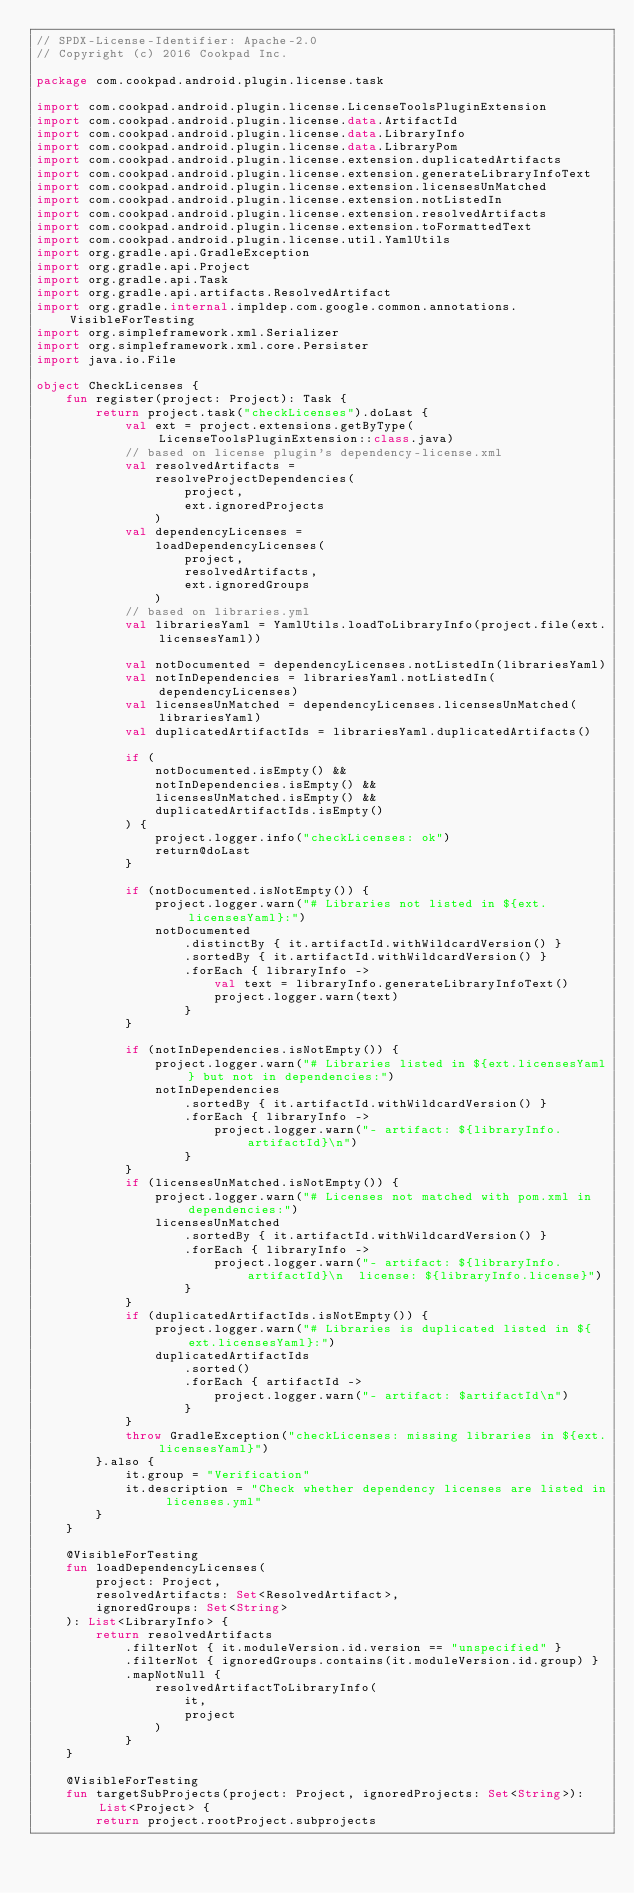Convert code to text. <code><loc_0><loc_0><loc_500><loc_500><_Kotlin_>// SPDX-License-Identifier: Apache-2.0
// Copyright (c) 2016 Cookpad Inc.

package com.cookpad.android.plugin.license.task

import com.cookpad.android.plugin.license.LicenseToolsPluginExtension
import com.cookpad.android.plugin.license.data.ArtifactId
import com.cookpad.android.plugin.license.data.LibraryInfo
import com.cookpad.android.plugin.license.data.LibraryPom
import com.cookpad.android.plugin.license.extension.duplicatedArtifacts
import com.cookpad.android.plugin.license.extension.generateLibraryInfoText
import com.cookpad.android.plugin.license.extension.licensesUnMatched
import com.cookpad.android.plugin.license.extension.notListedIn
import com.cookpad.android.plugin.license.extension.resolvedArtifacts
import com.cookpad.android.plugin.license.extension.toFormattedText
import com.cookpad.android.plugin.license.util.YamlUtils
import org.gradle.api.GradleException
import org.gradle.api.Project
import org.gradle.api.Task
import org.gradle.api.artifacts.ResolvedArtifact
import org.gradle.internal.impldep.com.google.common.annotations.VisibleForTesting
import org.simpleframework.xml.Serializer
import org.simpleframework.xml.core.Persister
import java.io.File

object CheckLicenses {
    fun register(project: Project): Task {
        return project.task("checkLicenses").doLast {
            val ext = project.extensions.getByType(LicenseToolsPluginExtension::class.java)
            // based on license plugin's dependency-license.xml
            val resolvedArtifacts =
                resolveProjectDependencies(
                    project,
                    ext.ignoredProjects
                )
            val dependencyLicenses =
                loadDependencyLicenses(
                    project,
                    resolvedArtifacts,
                    ext.ignoredGroups
                )
            // based on libraries.yml
            val librariesYaml = YamlUtils.loadToLibraryInfo(project.file(ext.licensesYaml))

            val notDocumented = dependencyLicenses.notListedIn(librariesYaml)
            val notInDependencies = librariesYaml.notListedIn(dependencyLicenses)
            val licensesUnMatched = dependencyLicenses.licensesUnMatched(librariesYaml)
            val duplicatedArtifactIds = librariesYaml.duplicatedArtifacts()

            if (
                notDocumented.isEmpty() &&
                notInDependencies.isEmpty() &&
                licensesUnMatched.isEmpty() &&
                duplicatedArtifactIds.isEmpty()
            ) {
                project.logger.info("checkLicenses: ok")
                return@doLast
            }

            if (notDocumented.isNotEmpty()) {
                project.logger.warn("# Libraries not listed in ${ext.licensesYaml}:")
                notDocumented
                    .distinctBy { it.artifactId.withWildcardVersion() }
                    .sortedBy { it.artifactId.withWildcardVersion() }
                    .forEach { libraryInfo ->
                        val text = libraryInfo.generateLibraryInfoText()
                        project.logger.warn(text)
                    }
            }

            if (notInDependencies.isNotEmpty()) {
                project.logger.warn("# Libraries listed in ${ext.licensesYaml} but not in dependencies:")
                notInDependencies
                    .sortedBy { it.artifactId.withWildcardVersion() }
                    .forEach { libraryInfo ->
                        project.logger.warn("- artifact: ${libraryInfo.artifactId}\n")
                    }
            }
            if (licensesUnMatched.isNotEmpty()) {
                project.logger.warn("# Licenses not matched with pom.xml in dependencies:")
                licensesUnMatched
                    .sortedBy { it.artifactId.withWildcardVersion() }
                    .forEach { libraryInfo ->
                        project.logger.warn("- artifact: ${libraryInfo.artifactId}\n  license: ${libraryInfo.license}")
                    }
            }
            if (duplicatedArtifactIds.isNotEmpty()) {
                project.logger.warn("# Libraries is duplicated listed in ${ext.licensesYaml}:")
                duplicatedArtifactIds
                    .sorted()
                    .forEach { artifactId ->
                        project.logger.warn("- artifact: $artifactId\n")
                    }
            }
            throw GradleException("checkLicenses: missing libraries in ${ext.licensesYaml}")
        }.also {
            it.group = "Verification"
            it.description = "Check whether dependency licenses are listed in licenses.yml"
        }
    }

    @VisibleForTesting
    fun loadDependencyLicenses(
        project: Project,
        resolvedArtifacts: Set<ResolvedArtifact>,
        ignoredGroups: Set<String>
    ): List<LibraryInfo> {
        return resolvedArtifacts
            .filterNot { it.moduleVersion.id.version == "unspecified" }
            .filterNot { ignoredGroups.contains(it.moduleVersion.id.group) }
            .mapNotNull {
                resolvedArtifactToLibraryInfo(
                    it,
                    project
                )
            }
    }

    @VisibleForTesting
    fun targetSubProjects(project: Project, ignoredProjects: Set<String>): List<Project> {
        return project.rootProject.subprojects</code> 